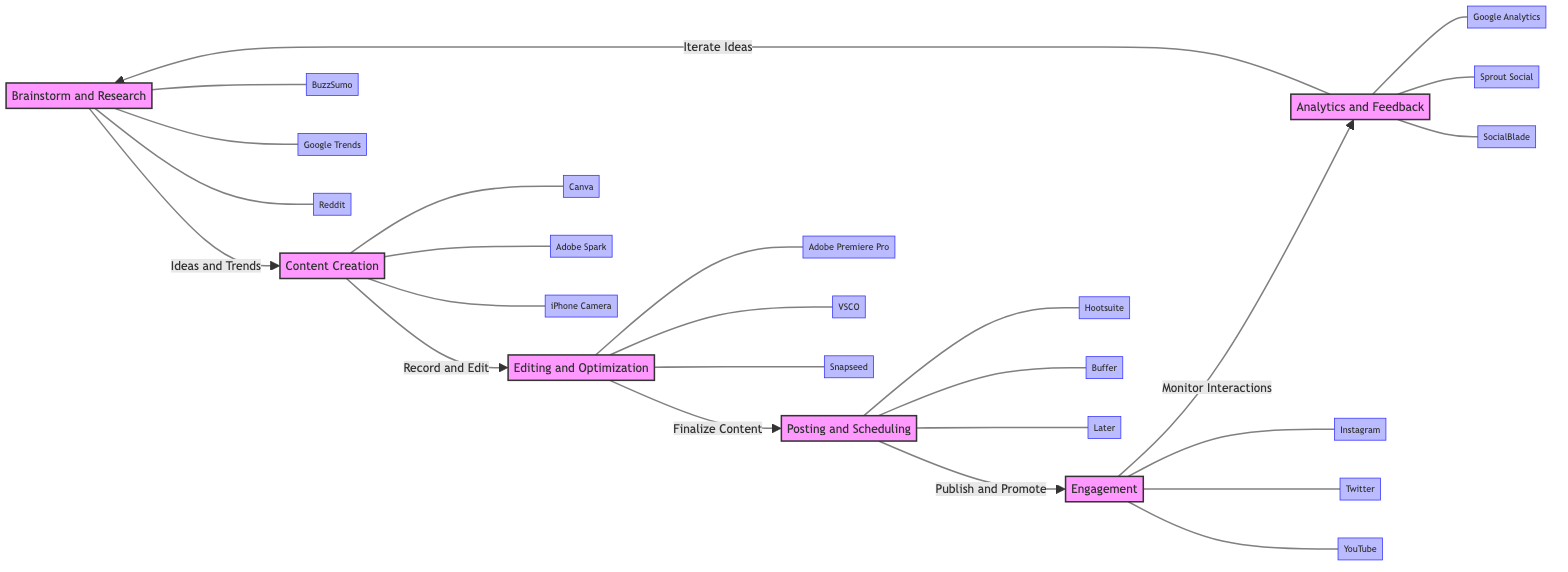What is the first step in the workflow? The first step in the workflow as shown in the diagram is "Brainstorm and Research," which is the node that initiates the flow.
Answer: Brainstorm and Research How many tools are linked to the "Content Creation" step? There are three tools linked to the "Content Creation" step: Canva, Adobe Spark, and iPhone Camera, which are shown branching from this node.
Answer: 3 Which tool is used for "Analytics and Feedback"? The tools linked to "Analytics and Feedback" are Google Analytics, Sprout Social, and SocialBlade, but the question specifically asks for one tool; Google Analytics is one of them listed.
Answer: Google Analytics How do you move from "Engagement" to "Brainstorm and Research"? You move from "Engagement" to "Brainstorm and Research" by iterating on ideas, which is represented by the arrow connecting these two nodes in the diagram.
Answer: Iterate Ideas What is the relationship between "Editing and Optimization" and "Content Creation"? The relationship is that "Content Creation" leads to "Editing and Optimization," meaning that once content is created, it must be edited and optimized before posting.
Answer: Leads to Which tool is mentioned first for the "Brainstorm and Research" phase? The first tool mentioned for the "Brainstorm and Research" phase is BuzzSumo, which is the first tool linked to the initial step.
Answer: BuzzSumo What is the last step in the workflow? The last step in the workflow is "Analytics and Feedback," which is the final node before the workflow loops back to the first step.
Answer: Analytics and Feedback How many distinct phases are represented in the diagram? The diagram represents six distinct phases, which are Brainstorm and Research, Content Creation, Editing and Optimization, Posting and Scheduling, Engagement, and Analytics and Feedback.
Answer: 6 Which tool is associated with the "Posting and Scheduling" phase? The tools associated with the "Posting and Scheduling" phase include Hootsuite, Buffer, and Later; choosing one, I’ll mention Hootsuite here.
Answer: Hootsuite 